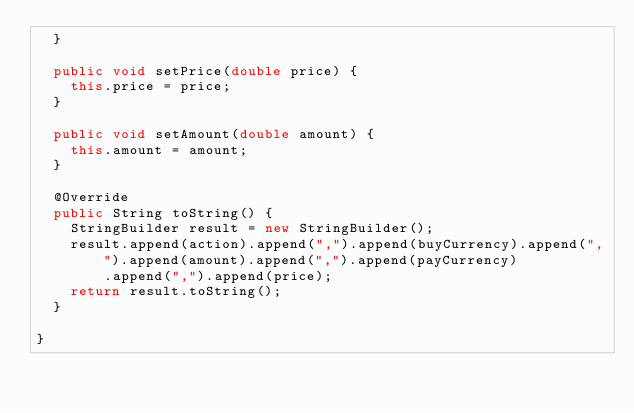<code> <loc_0><loc_0><loc_500><loc_500><_Java_>	}

	public void setPrice(double price) {
		this.price = price;
	}

	public void setAmount(double amount) {
		this.amount = amount;
	}

	@Override
	public String toString() {
		StringBuilder result = new StringBuilder();
		result.append(action).append(",").append(buyCurrency).append(",").append(amount).append(",").append(payCurrency)
				.append(",").append(price);
		return result.toString();
	}

}
</code> 